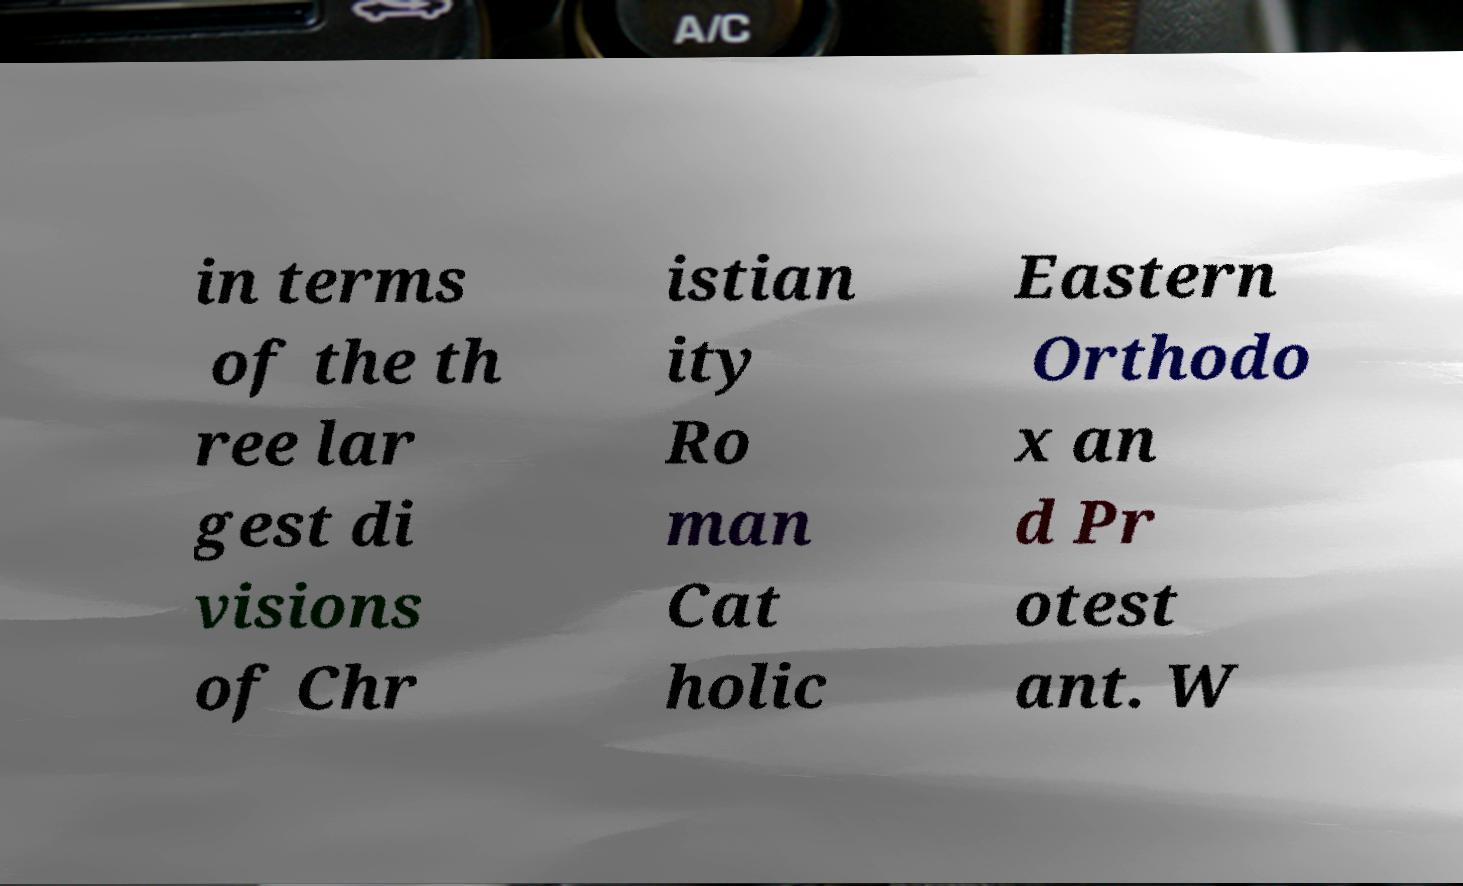For documentation purposes, I need the text within this image transcribed. Could you provide that? in terms of the th ree lar gest di visions of Chr istian ity Ro man Cat holic Eastern Orthodo x an d Pr otest ant. W 